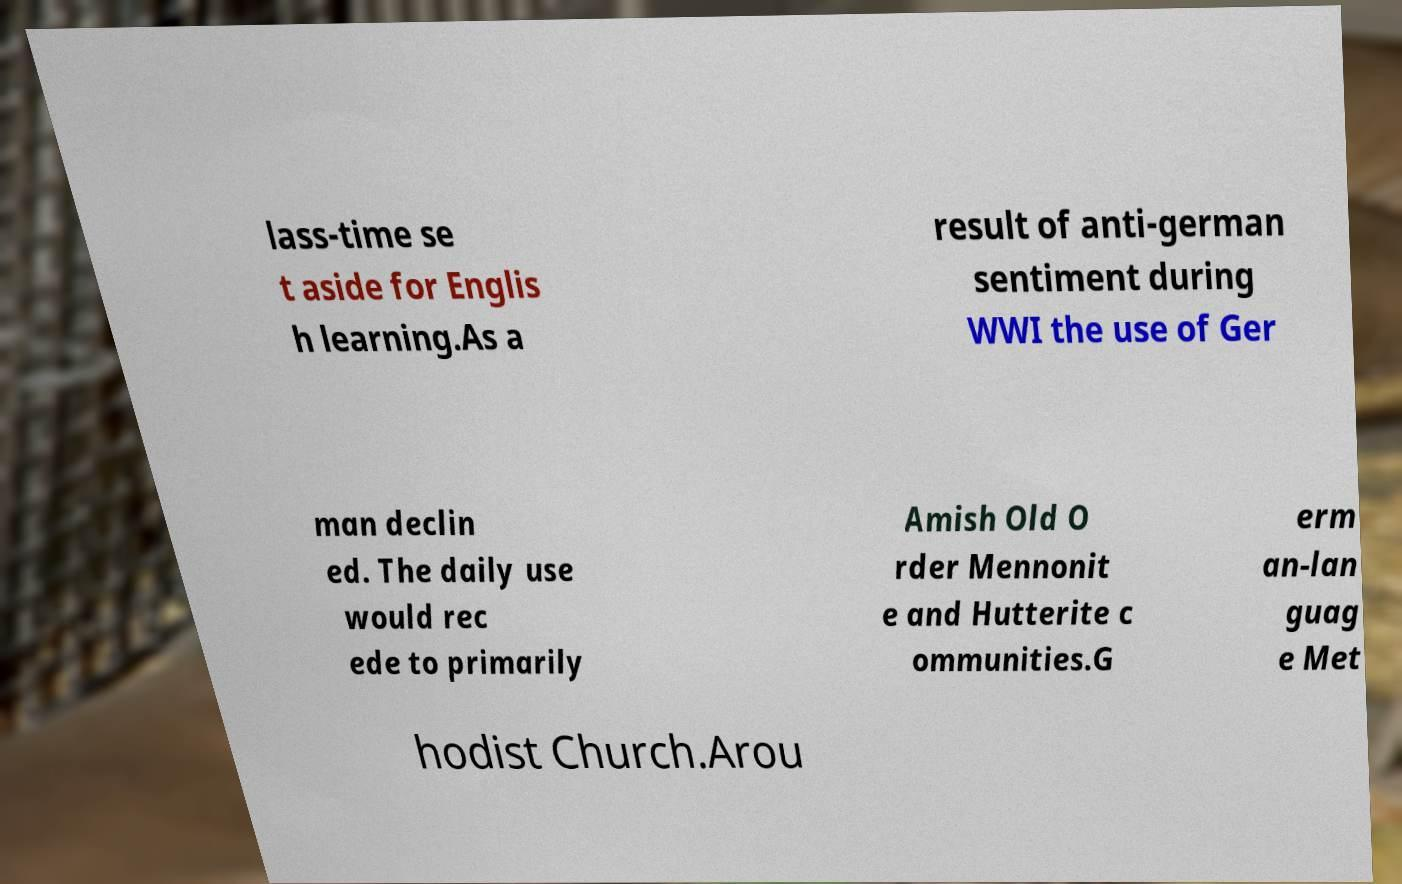What messages or text are displayed in this image? I need them in a readable, typed format. lass-time se t aside for Englis h learning.As a result of anti-german sentiment during WWI the use of Ger man declin ed. The daily use would rec ede to primarily Amish Old O rder Mennonit e and Hutterite c ommunities.G erm an-lan guag e Met hodist Church.Arou 